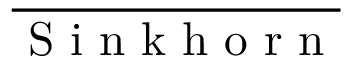Convert formula to latex. <formula><loc_0><loc_0><loc_500><loc_500>\overline { S i n k h o r n }</formula> 